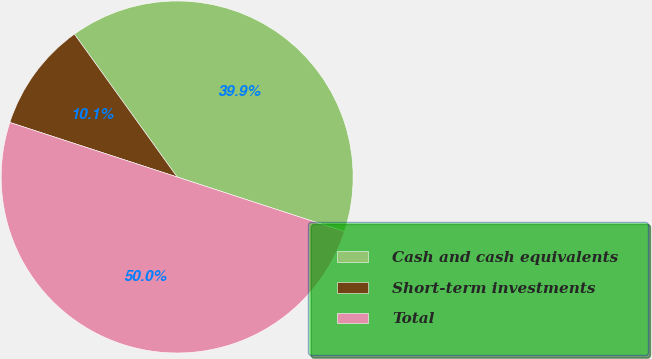Convert chart. <chart><loc_0><loc_0><loc_500><loc_500><pie_chart><fcel>Cash and cash equivalents<fcel>Short-term investments<fcel>Total<nl><fcel>39.94%<fcel>10.06%<fcel>50.0%<nl></chart> 